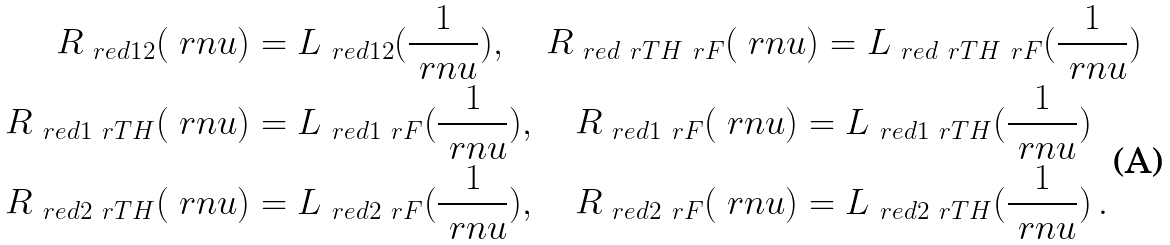Convert formula to latex. <formula><loc_0><loc_0><loc_500><loc_500>R _ { \ r e d 1 2 } ( \ r n u ) & = L _ { \ r e d 1 2 } ( \frac { 1 } { \ r n u } ) , \quad R _ { \ r e d \ r T H \ r F } ( \ r n u ) = L _ { \ r e d \ r T H \ r F } ( \frac { 1 } { \ r n u } ) \\ R _ { \ r e d 1 \ r T H } ( \ r n u ) & = L _ { \ r e d 1 \ r F } ( \frac { 1 } { \ r n u } ) , \quad R _ { \ r e d 1 \ r F } ( \ r n u ) = L _ { \ r e d 1 \ r T H } ( \frac { 1 } { \ r n u } ) \\ R _ { \ r e d 2 \ r T H } ( \ r n u ) & = L _ { \ r e d 2 \ r F } ( \frac { 1 } { \ r n u } ) , \quad R _ { \ r e d 2 \ r F } ( \ r n u ) = L _ { \ r e d 2 \ r T H } ( \frac { 1 } { \ r n u } ) \, .</formula> 